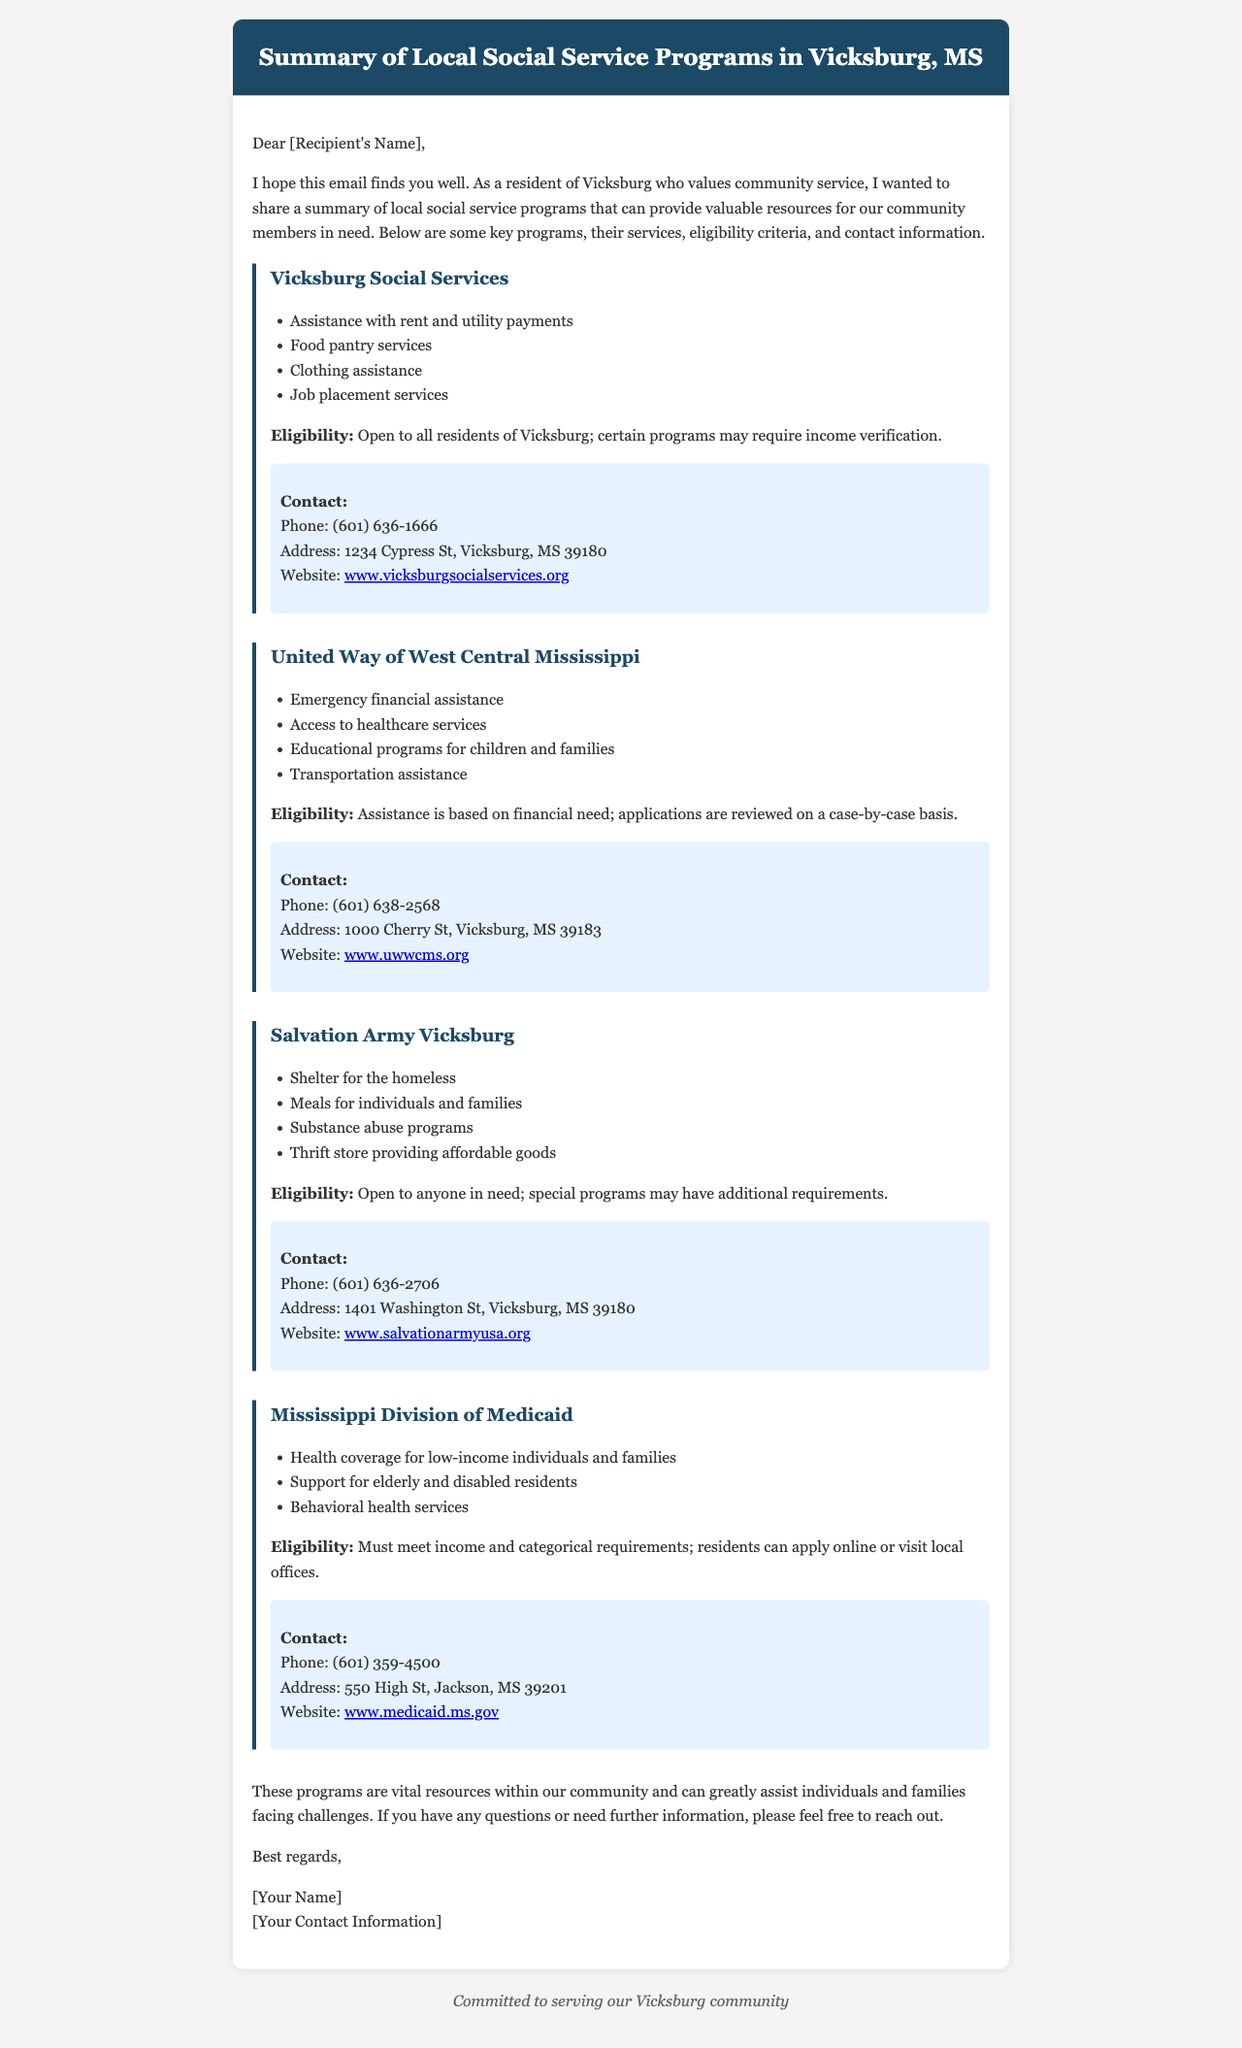What services does Vicksburg Social Services provide? The email lists assistance with rent and utility payments, food pantry services, clothing assistance, and job placement services.
Answer: Rent and utility payments, food pantry, clothing assistance, job placement services What is the phone number for United Way of West Central Mississippi? The document states that the contact phone number for United Way of West Central Mississippi is provided.
Answer: (601) 638-2568 What type of assistance does the Salvation Army Vicksburg offer? The document details several services including shelter for the homeless, meals for individuals and families, substance abuse programs, and a thrift store.
Answer: Shelter for the homeless, meals, substance abuse programs, thrift store Who is eligible for the Mississippi Division of Medicaid services? The email explains that individuals must meet income and categorical requirements to be eligible for Medicaid.
Answer: Income and categorical requirements What is the address of Vicksburg Social Services? The email provides an address for Vicksburg Social Services along with its services.
Answer: 1234 Cypress St, Vicksburg, MS 39180 How can residents apply for Mississippi Division of Medicaid? The document mentions that residents can apply online or visit local offices for Medicaid services.
Answer: Online or visit local offices What is the website for the Salvation Army Vicksburg? The email lists the website where more information can be found about the Salvation Army Vicksburg.
Answer: www.salvationarmyusa.org What eligibility criteria does the United Way of West Central Mississippi have? The email states that assistance is based on financial need and that applications are reviewed on a case-by-case basis.
Answer: Financial need, case-by-case basis 